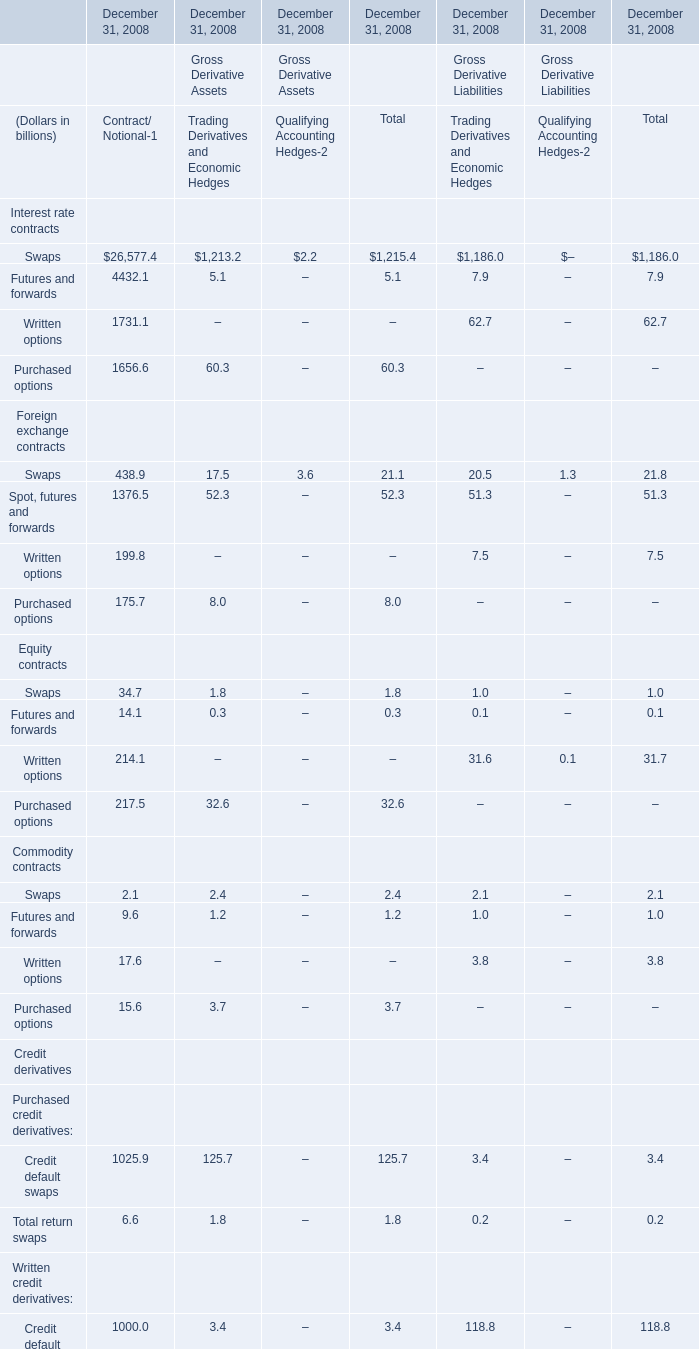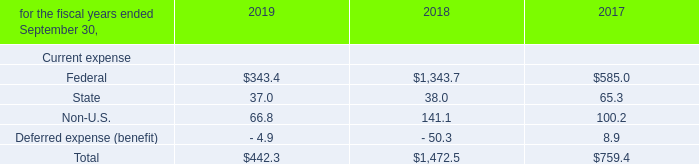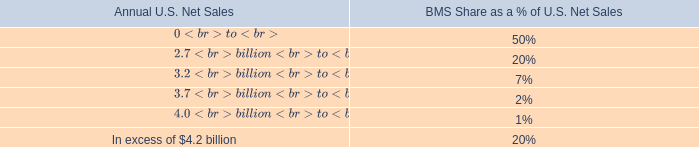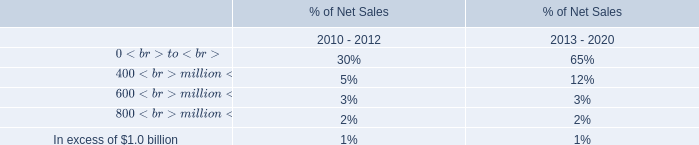Between Gross Derivative Assets and Gross Derivative Liabilities in 2008 ,what is the total amount of it while whose total return swaps is greater than 0.2? (in dollars in billions) 
Answer: 62.3. 